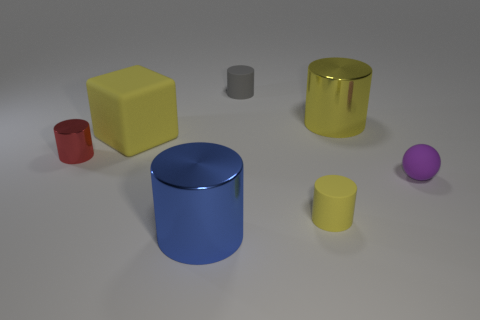Imagine these objects are part of a still life painting. What mood or theme do you think the artist is conveying? If these objects were part of a still life painting, the artist might be exploring themes of simplicity and harmony through the use of basic geometric shapes and a subdued color palette. The arrangement and the soft lighting could be suggesting a sense of calm and order, inviting the viewer to contemplate the beauty in everyday simplicity. 